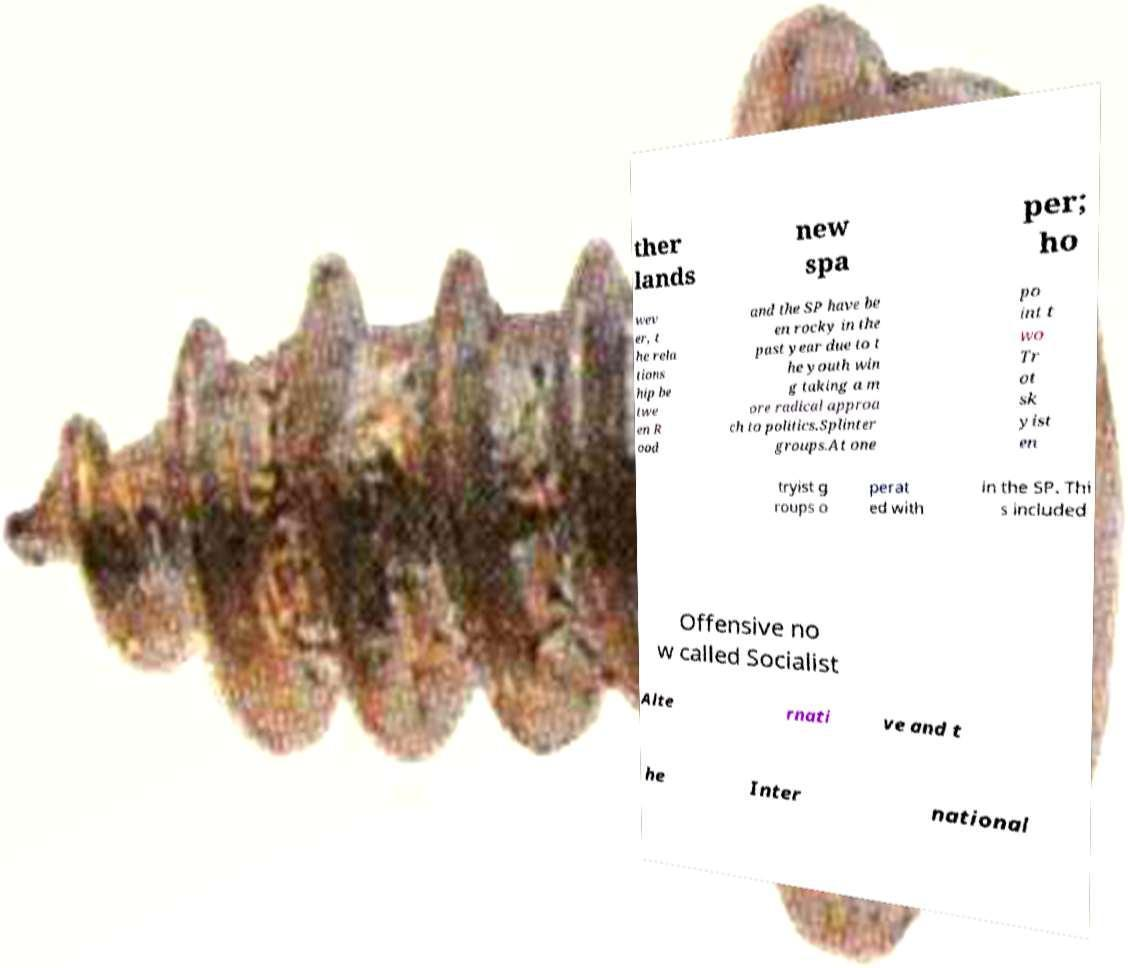What messages or text are displayed in this image? I need them in a readable, typed format. ther lands new spa per; ho wev er, t he rela tions hip be twe en R ood and the SP have be en rocky in the past year due to t he youth win g taking a m ore radical approa ch to politics.Splinter groups.At one po int t wo Tr ot sk yist en tryist g roups o perat ed with in the SP. Thi s included Offensive no w called Socialist Alte rnati ve and t he Inter national 